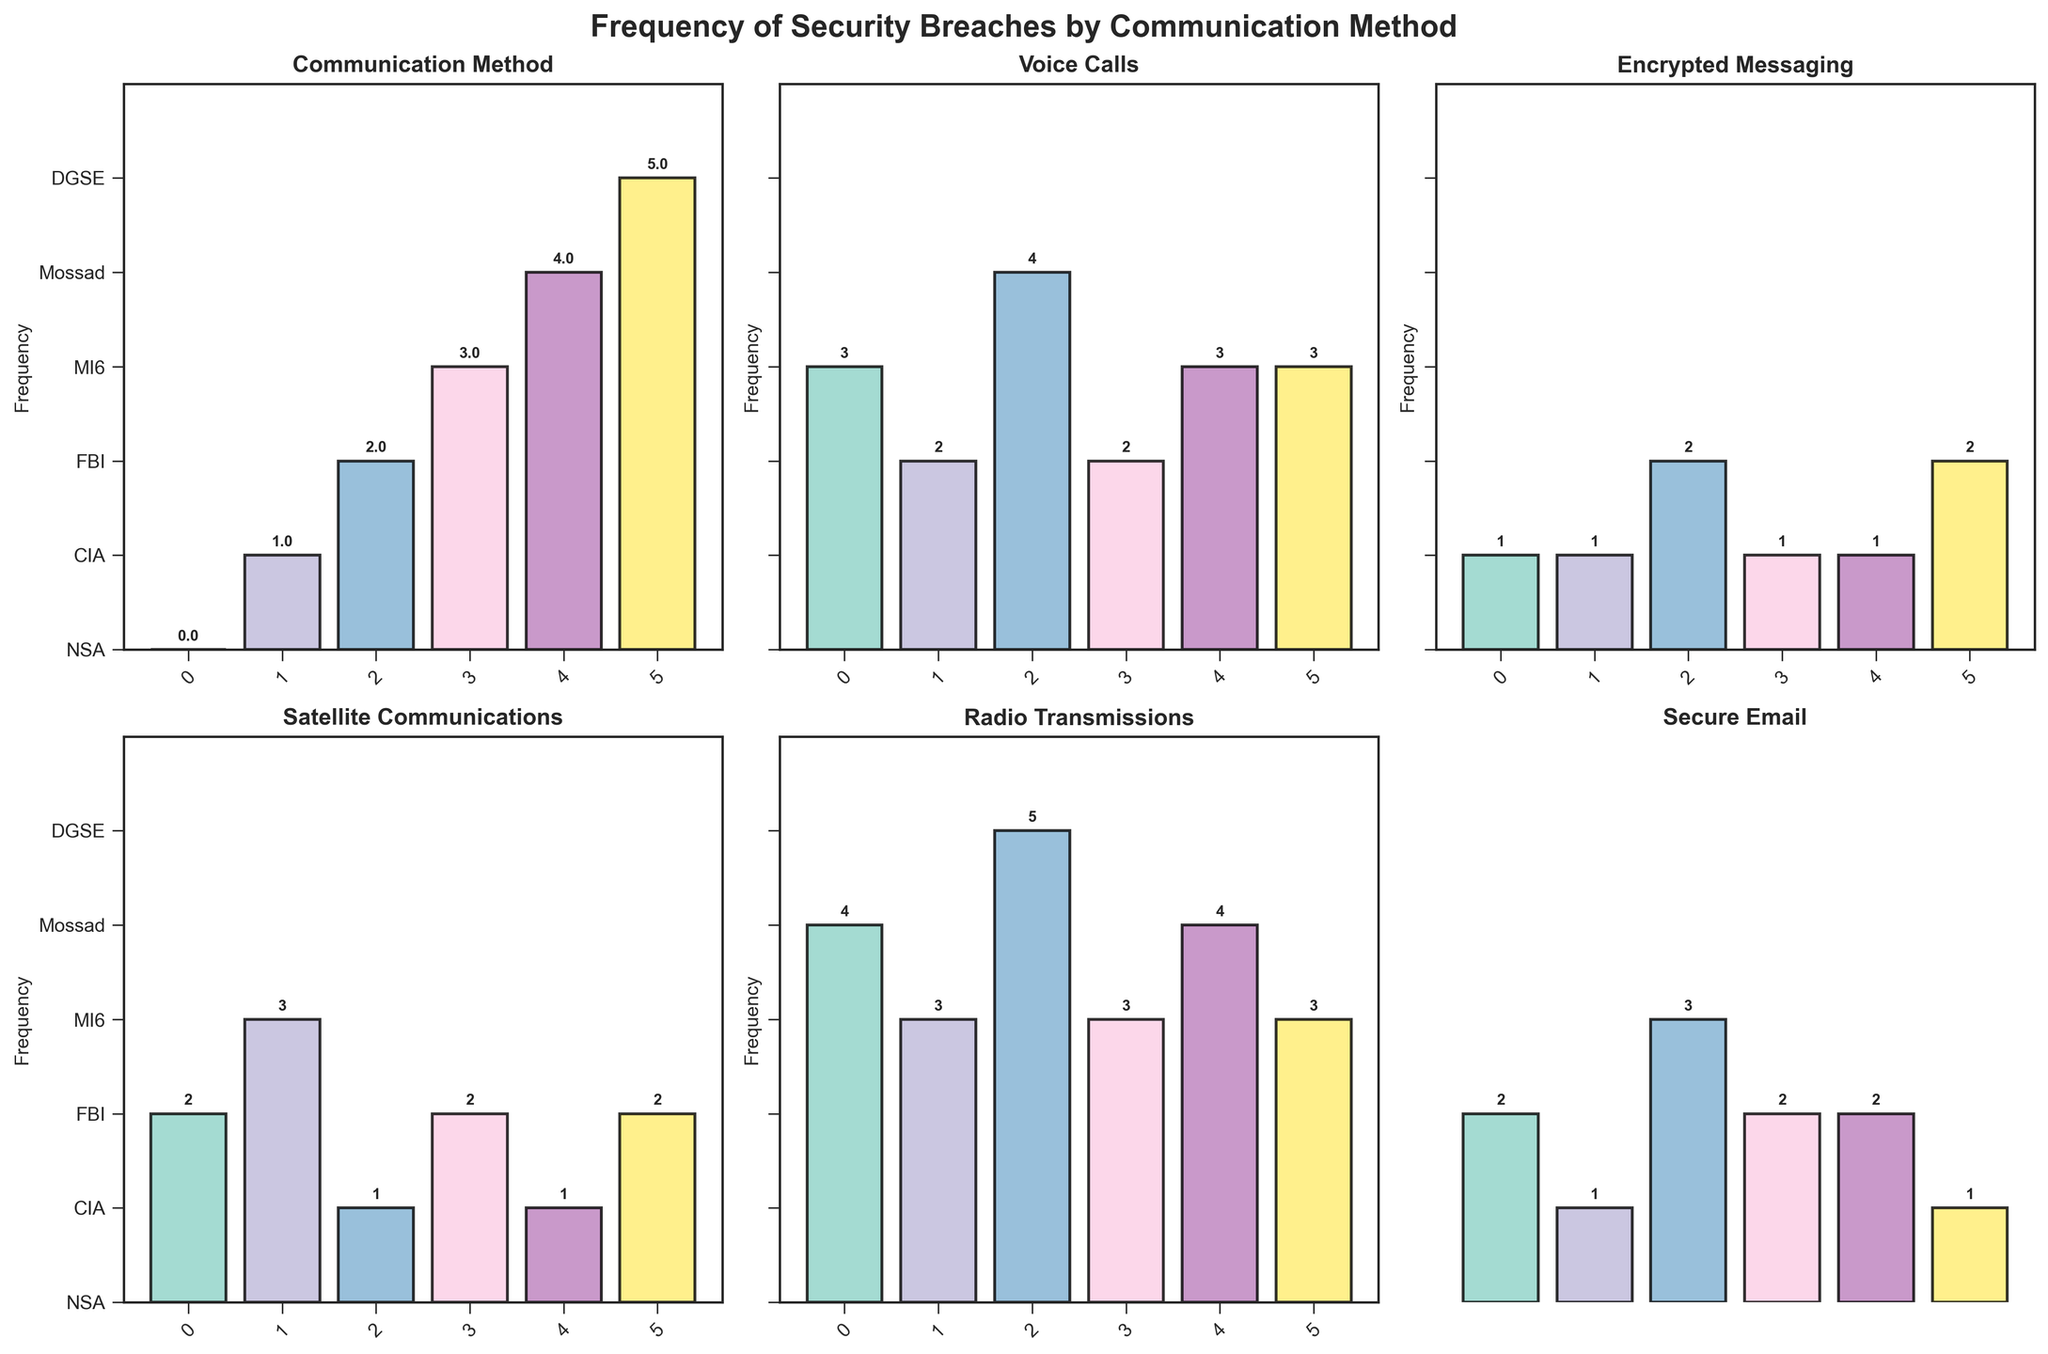What is the title of the figure? The title is located at the top of the figure and reads "Frequency of Security Breaches by Communication Method."
Answer: Frequency of Security Breaches by Communication Method Which communication method has the highest frequency of security breaches for the FBI? For the FBI, the bar with the greatest height is for Radio Transmissions, indicating it has the highest frequency.
Answer: Radio Transmissions How many breaches have been recorded for Satellite Communications at the CIA? Looking at the CIA's bar for Satellite Communications, the number at the top of the bar is 3.
Answer: 3 Which agency encountered the least number of security breaches via Encrypted Messaging? The lowest bar in the Encrypted Messaging subplot belongs to the NSA, CIA, MI6, and Mossad, all with a frequency of 1.
Answer: NSA, CIA, MI6, Mossad What is the average frequency of security breaches for Mossad across all communication methods? Sum the frequencies for Mossad (3+1+1+4+2) to get 11, then divide by the number of methods (5) to find the average.
Answer: 2.2 Which agency's Radio Transmissions have encountered more breaches, DGSE or MI6? By comparing the bars for DGSE and MI6 in the Radio Transmissions subplot, DGSE has 3 breaches, and MI6 has 3 breaches as well.
Answer: Equal What is the total number of security breaches recorded for Secure Email across all agencies? Add up the values for Secure Email for all agencies: NSA (2), CIA (1), FBI (3), MI6 (2), Mossad (2), and DGSE (1), summing to (2 + 1 + 3 + 2 + 2 + 1).
Answer: 11 Which communication method has the most variation in the frequency of security breaches? Checking across all subplots, Radio Transmissions show a range from 3 to 5, implying it might have the most variation.
Answer: Radio Transmissions Comparing Voice Calls and Secure Email, which method is consistently less secure across all agencies? By examining all bars, Voice Calls tend to have higher values overall compared to Secure Email, indicating that Voice Calls may be less secure.
Answer: Voice Calls 